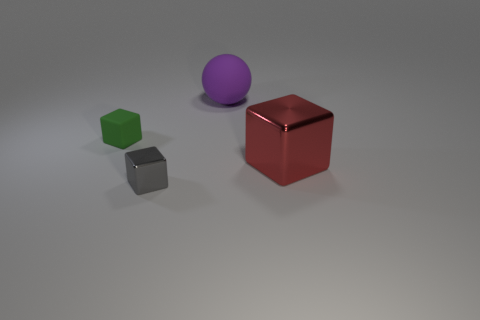Are there any big blocks to the right of the red cube?
Make the answer very short. No. How many objects are large red cubes or green things behind the gray shiny cube?
Keep it short and to the point. 2. Is there a purple matte thing that is to the right of the big object that is in front of the small green matte object?
Keep it short and to the point. No. There is a rubber thing that is to the left of the large object to the left of the big thing in front of the big purple sphere; what is its shape?
Provide a short and direct response. Cube. What is the color of the block that is both left of the big purple rubber object and in front of the small green rubber thing?
Ensure brevity in your answer.  Gray. There is a matte thing behind the green rubber thing; what shape is it?
Ensure brevity in your answer.  Sphere. The small thing that is the same material as the large purple ball is what shape?
Offer a very short reply. Cube. How many rubber things are either green objects or small objects?
Ensure brevity in your answer.  1. There is a tiny object to the right of the block behind the red thing; how many big matte spheres are on the left side of it?
Offer a very short reply. 0. Is the size of the metallic block left of the red shiny cube the same as the cube that is behind the large red block?
Provide a succinct answer. Yes. 